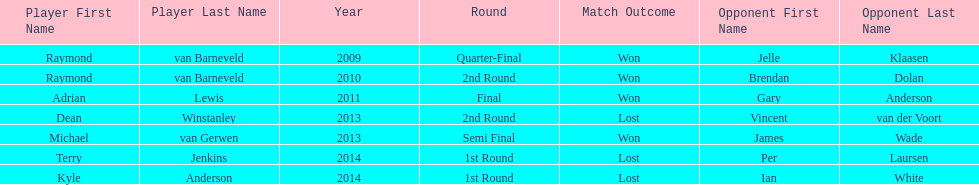How many champions were from norway? 0. 